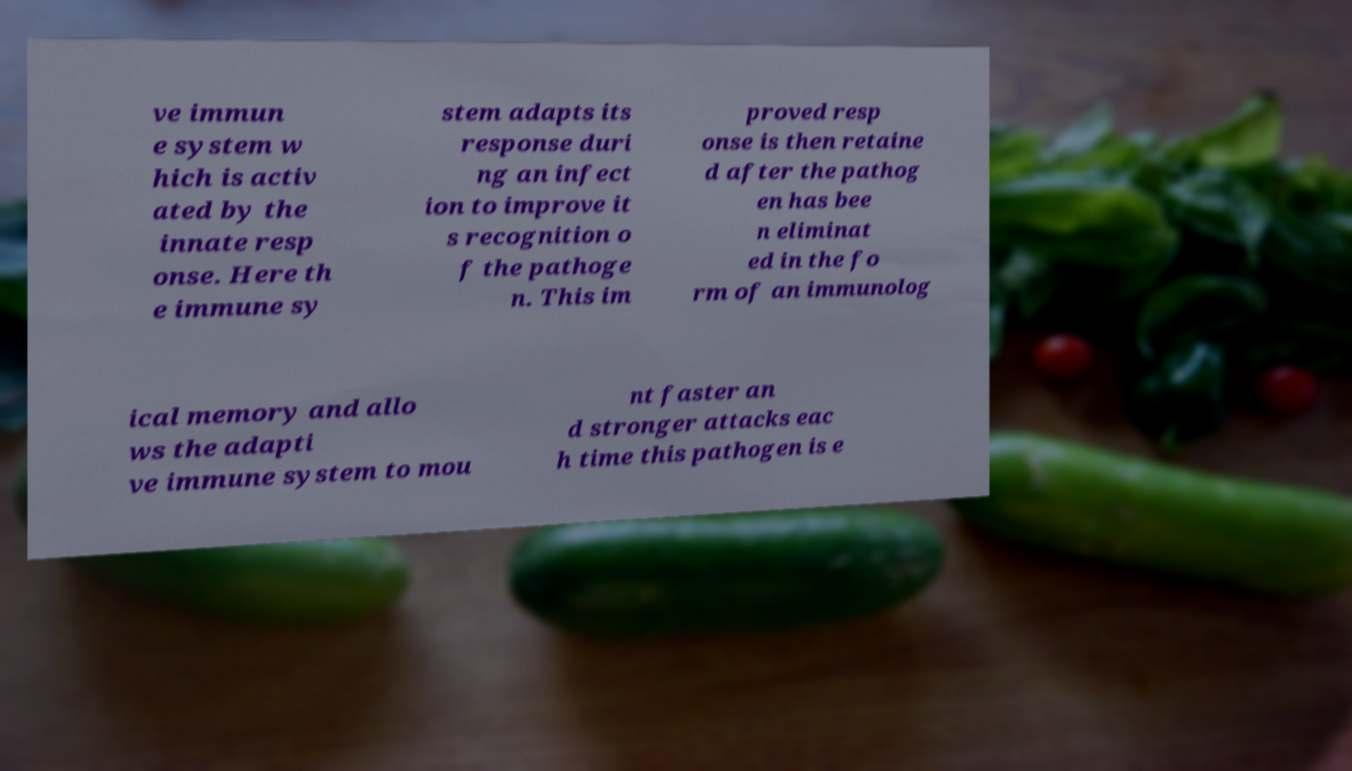Could you assist in decoding the text presented in this image and type it out clearly? ve immun e system w hich is activ ated by the innate resp onse. Here th e immune sy stem adapts its response duri ng an infect ion to improve it s recognition o f the pathoge n. This im proved resp onse is then retaine d after the pathog en has bee n eliminat ed in the fo rm of an immunolog ical memory and allo ws the adapti ve immune system to mou nt faster an d stronger attacks eac h time this pathogen is e 